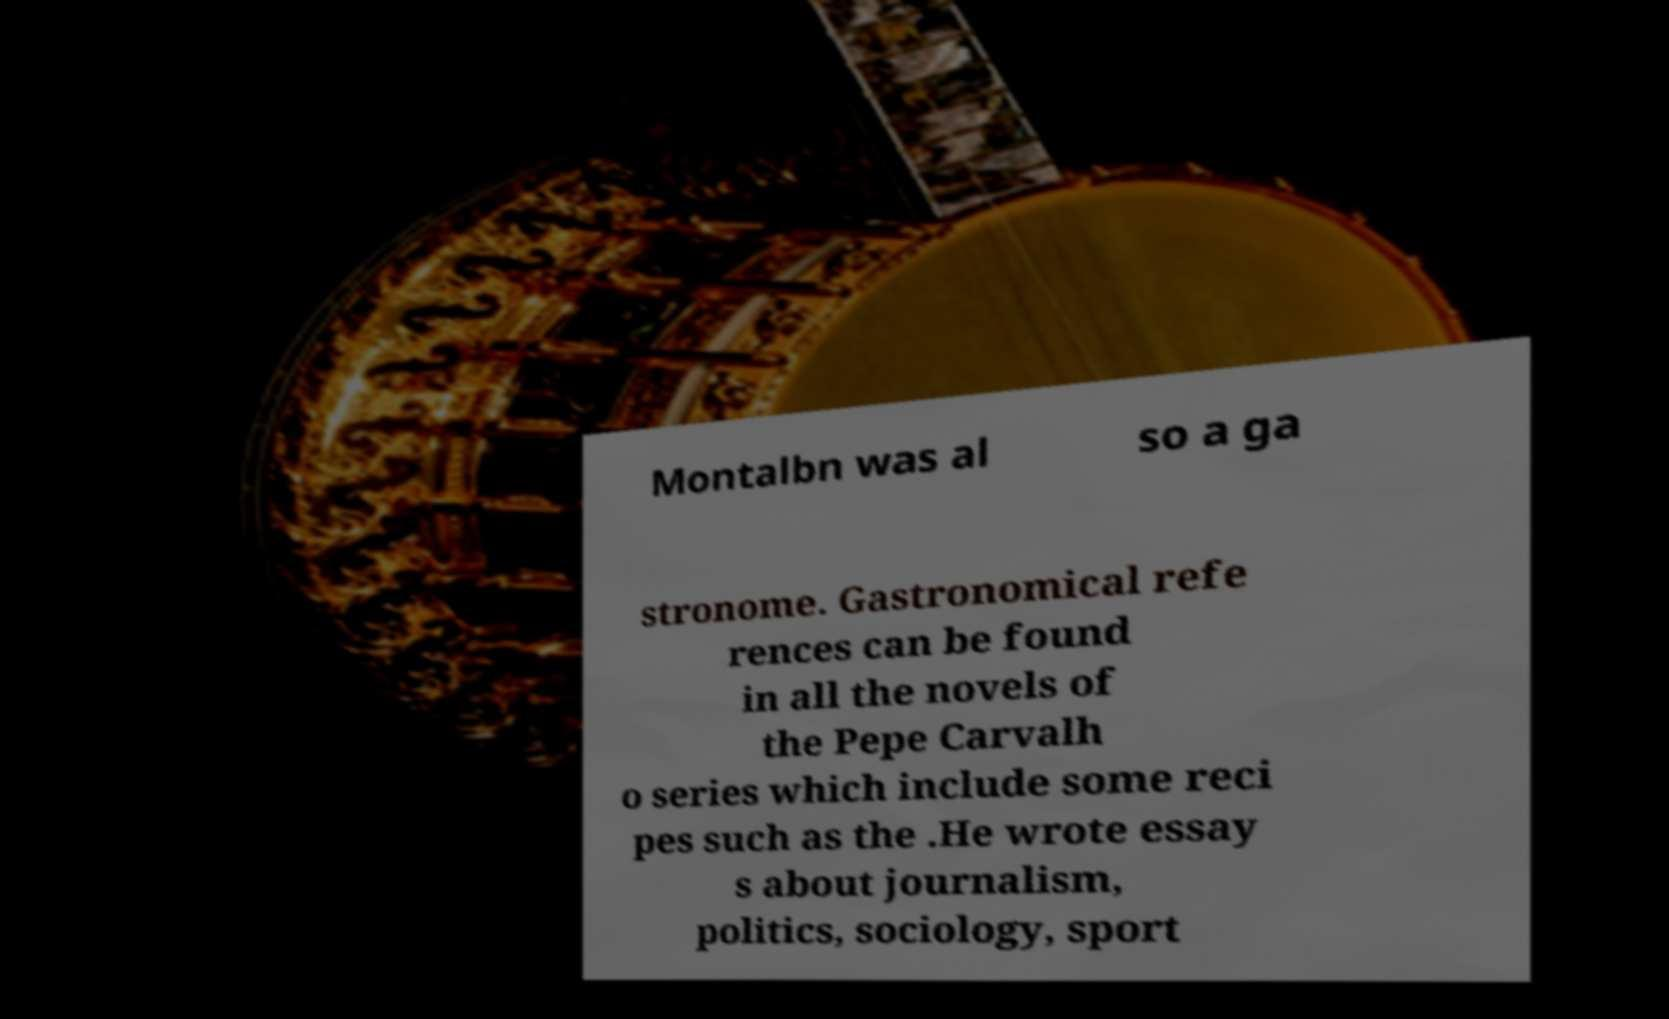Can you read and provide the text displayed in the image?This photo seems to have some interesting text. Can you extract and type it out for me? Montalbn was al so a ga stronome. Gastronomical refe rences can be found in all the novels of the Pepe Carvalh o series which include some reci pes such as the .He wrote essay s about journalism, politics, sociology, sport 